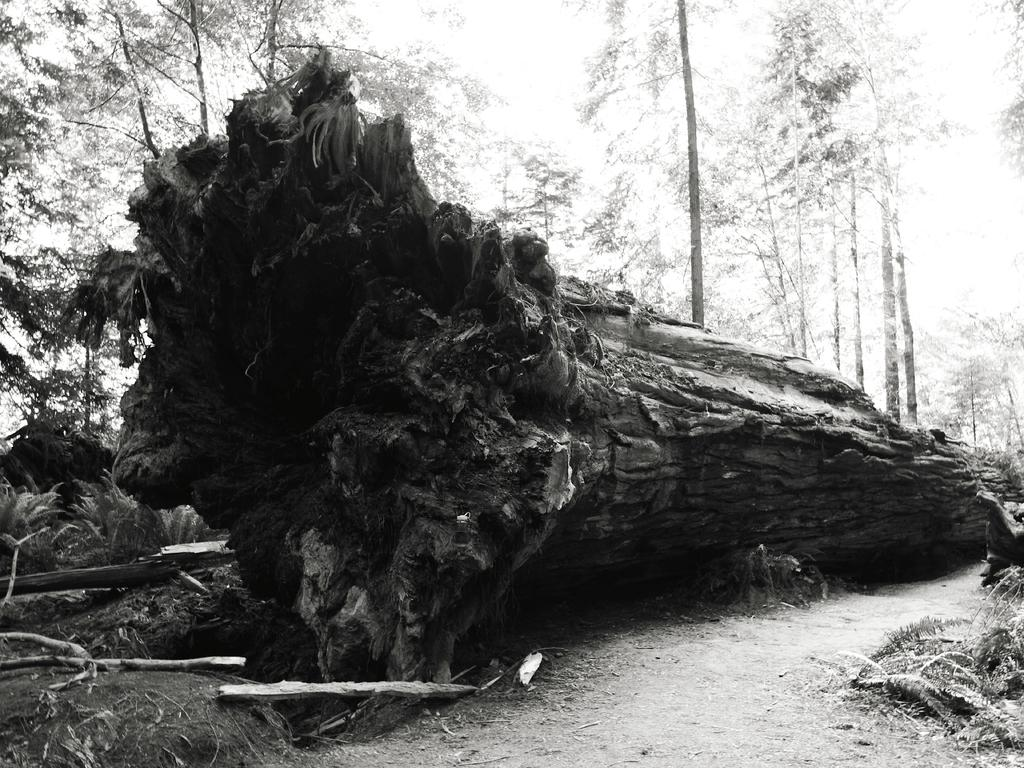Where was the picture taken? The picture was clicked outside the city. What can be seen on the ground in the image? There is a trunk of a tree laying on the ground. What is visible in the background of the image? The sky is visible in the background, along with trees and grass. What color of paint is used on the clam in the image? There is no clam present in the image, so the color of paint cannot be determined. 